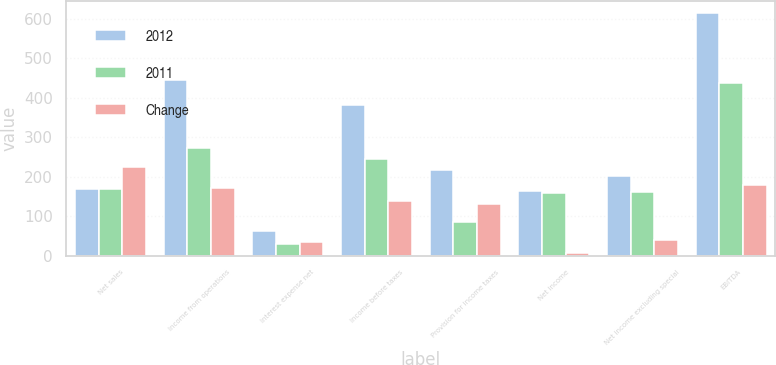<chart> <loc_0><loc_0><loc_500><loc_500><stacked_bar_chart><ecel><fcel>Net sales<fcel>Income from operations<fcel>Interest expense net<fcel>Income before taxes<fcel>Provision for income taxes<fcel>Net income<fcel>Net income excluding special<fcel>EBITDA<nl><fcel>2012<fcel>167.25<fcel>443.4<fcel>62.9<fcel>380.5<fcel>216.7<fcel>163.8<fcel>200.8<fcel>614.2<nl><fcel>2011<fcel>167.25<fcel>272.7<fcel>29.2<fcel>243.5<fcel>85.5<fcel>158<fcel>161.8<fcel>436.3<nl><fcel>Change<fcel>223.8<fcel>170.7<fcel>33.7<fcel>137<fcel>131.2<fcel>5.8<fcel>39<fcel>177.9<nl></chart> 